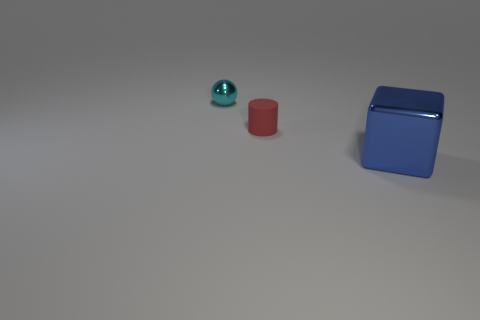Do the small ball and the small matte thing have the same color?
Keep it short and to the point. No. How many objects are small red rubber cylinders or objects in front of the cyan metallic thing?
Give a very brief answer. 2. Are there any red matte things that have the same size as the cyan object?
Your answer should be compact. Yes. Is the cyan ball made of the same material as the red cylinder?
Keep it short and to the point. No. What number of objects are either brown metal cylinders or small cyan spheres?
Provide a succinct answer. 1. How big is the red cylinder?
Give a very brief answer. Small. Are there fewer small green matte objects than cyan spheres?
Give a very brief answer. Yes. How many metallic blocks have the same color as the small cylinder?
Provide a succinct answer. 0. Does the small thing that is on the left side of the small red rubber thing have the same color as the tiny cylinder?
Provide a short and direct response. No. What is the shape of the small thing that is on the right side of the sphere?
Provide a short and direct response. Cylinder. 